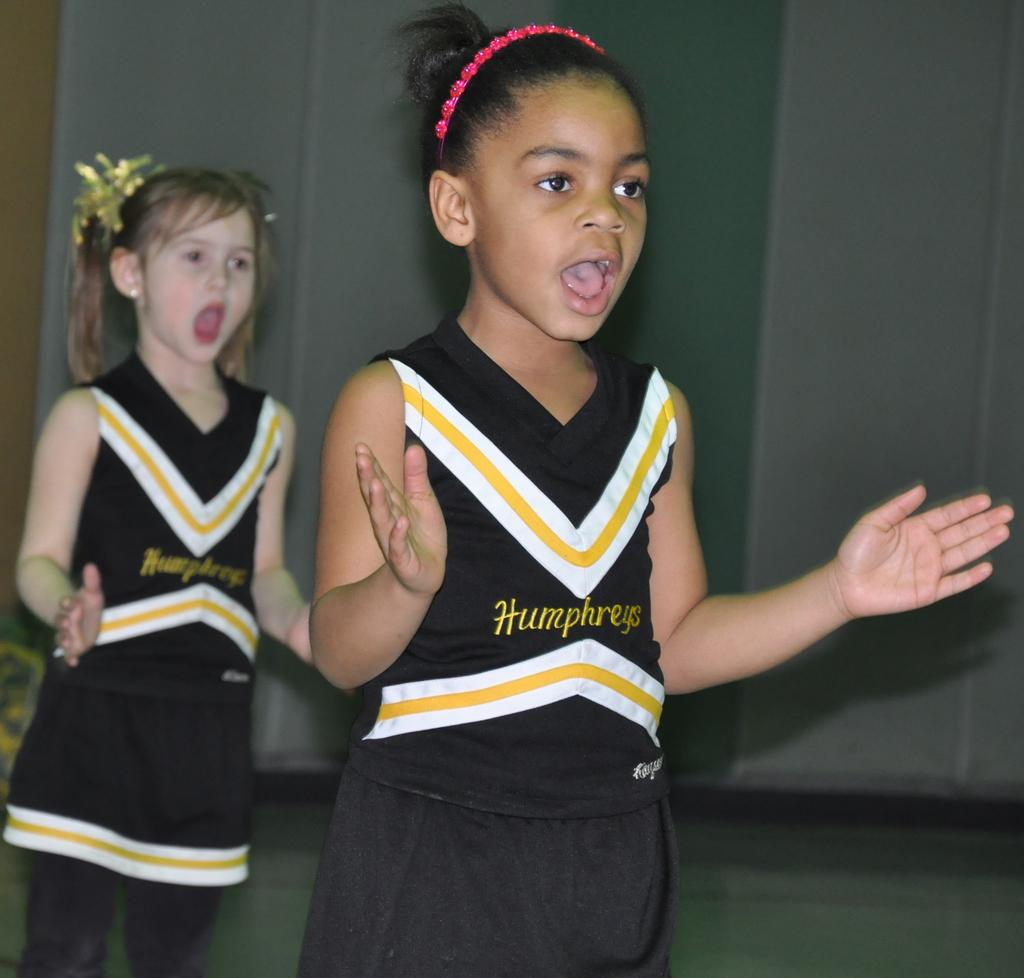<image>
Render a clear and concise summary of the photo. Girl wearing a black and yellow jersey that says Humphreys. 